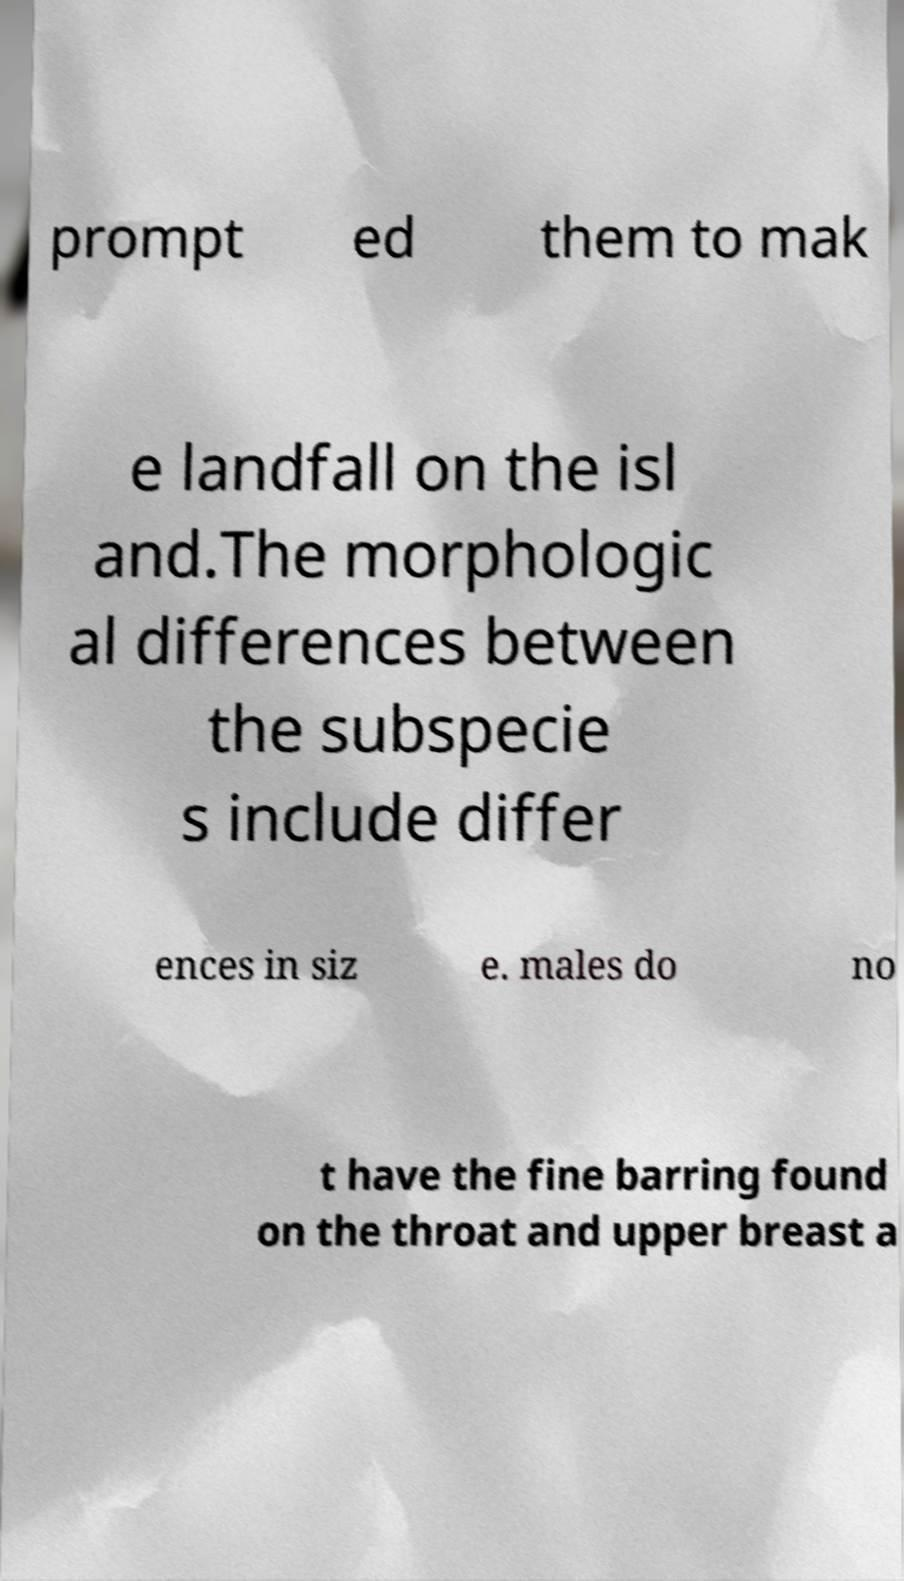What messages or text are displayed in this image? I need them in a readable, typed format. prompt ed them to mak e landfall on the isl and.The morphologic al differences between the subspecie s include differ ences in siz e. males do no t have the fine barring found on the throat and upper breast a 